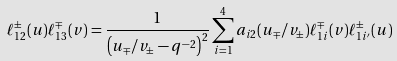<formula> <loc_0><loc_0><loc_500><loc_500>\ell _ { 1 2 } ^ { \pm } ( u ) \ell _ { 1 3 } ^ { \mp } ( v ) = \frac { 1 } { \left ( u _ { \mp } / v _ { \pm } - q ^ { - 2 } \right ) ^ { 2 } } \sum _ { i = 1 } ^ { 4 } a _ { i 2 } ( u _ { \mp } / v _ { \pm } ) \ell _ { 1 i } ^ { \mp } ( v ) \ell _ { 1 i ^ { \prime } } ^ { \pm } ( u )</formula> 